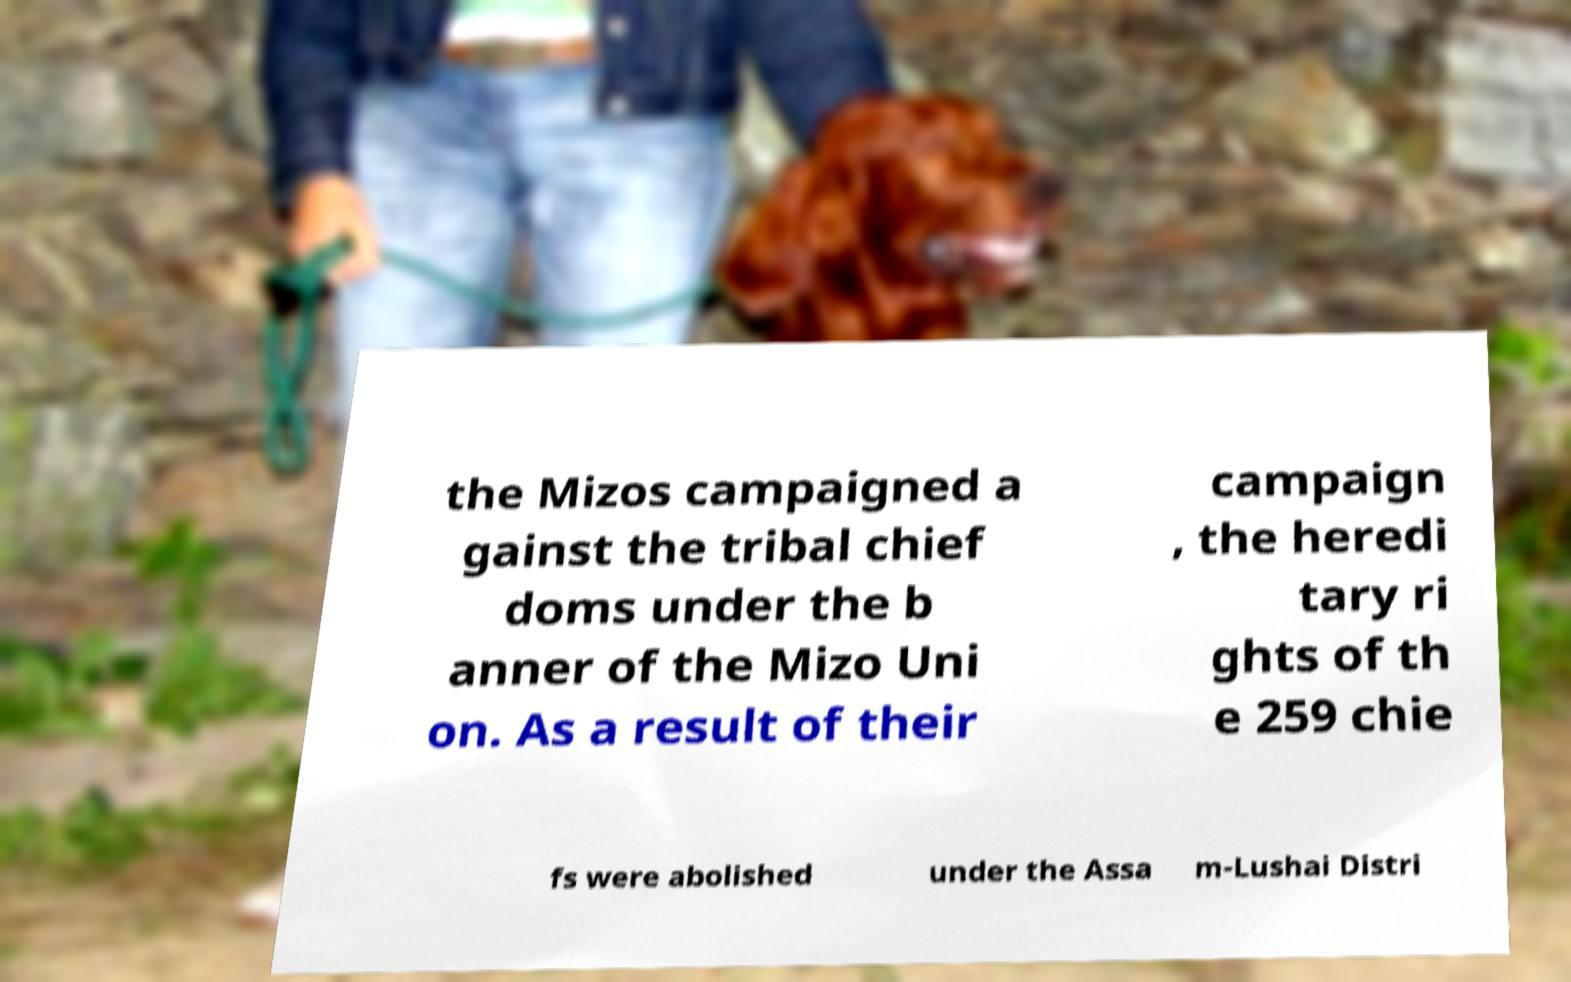Please identify and transcribe the text found in this image. the Mizos campaigned a gainst the tribal chief doms under the b anner of the Mizo Uni on. As a result of their campaign , the heredi tary ri ghts of th e 259 chie fs were abolished under the Assa m-Lushai Distri 